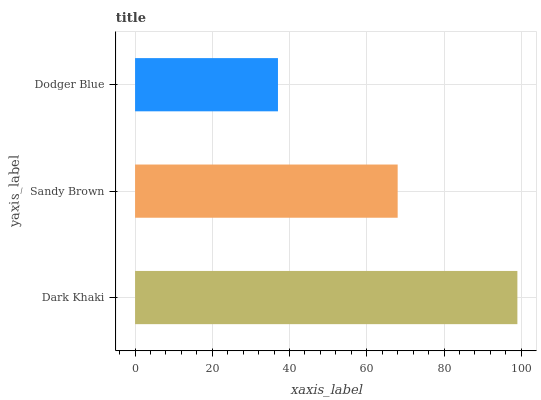Is Dodger Blue the minimum?
Answer yes or no. Yes. Is Dark Khaki the maximum?
Answer yes or no. Yes. Is Sandy Brown the minimum?
Answer yes or no. No. Is Sandy Brown the maximum?
Answer yes or no. No. Is Dark Khaki greater than Sandy Brown?
Answer yes or no. Yes. Is Sandy Brown less than Dark Khaki?
Answer yes or no. Yes. Is Sandy Brown greater than Dark Khaki?
Answer yes or no. No. Is Dark Khaki less than Sandy Brown?
Answer yes or no. No. Is Sandy Brown the high median?
Answer yes or no. Yes. Is Sandy Brown the low median?
Answer yes or no. Yes. Is Dodger Blue the high median?
Answer yes or no. No. Is Dodger Blue the low median?
Answer yes or no. No. 